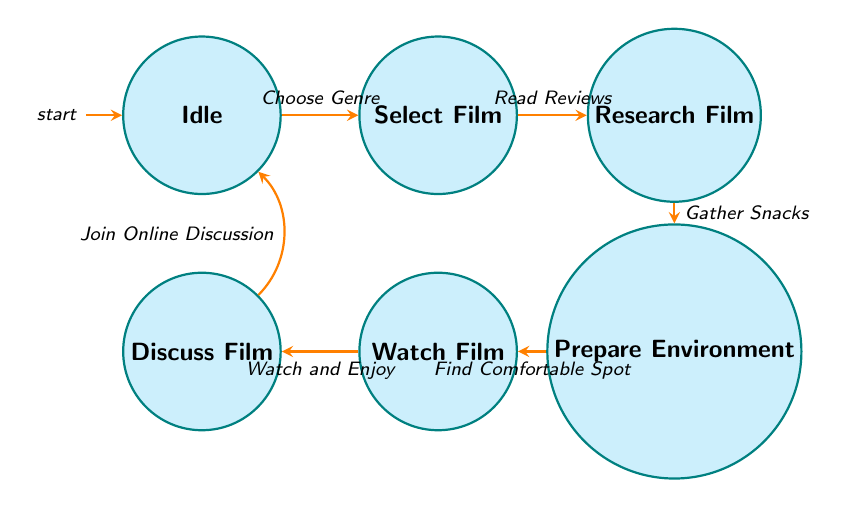What is the initial state of the diagram? The initial state is indicated by the label 'initial' on the Idle node. This shows that when the process begins, it starts in the Idle state.
Answer: Idle How many states are present in the diagram? Counting the nodes listed in the diagram, there are a total of 6 states: Idle, Select Film, Research Film, Prepare Environment, Watch Film, and Discuss Film.
Answer: 6 Which state comes after "Select Film"? The transition from the Select Film node, labeled 'Read Reviews', leads to Research Film. Thus, Research Film is the next state after Select Film.
Answer: Research Film What is the last state before returning to Idle? The state before returning to Idle, as indicated by the transition labeled 'Join Online Discussion', is Discuss Film. This means that after discussing the film, the routine goes back to Idle.
Answer: Discuss Film What is the transition that brings you from watching a film to discussing it? The transition between the Watch Film and Discuss Film states is named 'Watch and Enjoy'. This transition indicates that after watching the film, the next step is to discuss it.
Answer: Watch and Enjoy If you were to skip the Research Film state, which state would you go to next? If the Research Film state is skipped, one would move directly from Select Film to Prepare Environment, bypassing the Research Film entirely.
Answer: Prepare Environment How many transitions are there in the diagram? By counting the edges in the diagram, there are 6 transitions: Choose Genre, Read Reviews, Gather Snacks, Find Comfortable Spot, Watch and Enjoy, and Join Online Discussion.
Answer: 6 Which state requires you to gather snacks before proceeding? The state that requires gathering snacks before proceeding is Research Film, as indicated by the transition 'Gather Snacks', which leads to Prepare Environment.
Answer: Research Film What state do you enter after gathering snacks? After gathering snacks, the next state entered is Prepare Environment as shown by the transition indicated in the diagram.
Answer: Prepare Environment What action must be taken from the 'Discuss Film' state before returning to 'Idle'? The action that must be taken to return to 'Idle' from the Discuss Film state is to 'Join Online Discussion', which indicates the closure of the movie-watching routine.
Answer: Join Online Discussion 